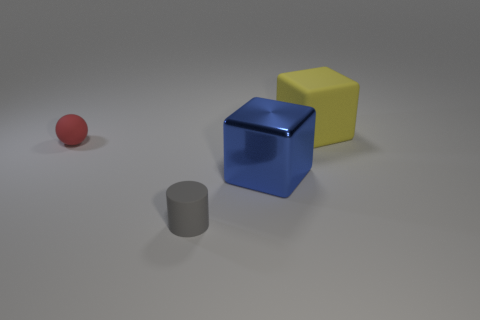Add 1 large purple matte objects. How many objects exist? 5 Add 1 small rubber cylinders. How many small rubber cylinders are left? 2 Add 4 blue shiny things. How many blue shiny things exist? 5 Subtract 0 gray balls. How many objects are left? 4 Subtract all spheres. How many objects are left? 3 Subtract all large blue cubes. Subtract all large shiny objects. How many objects are left? 2 